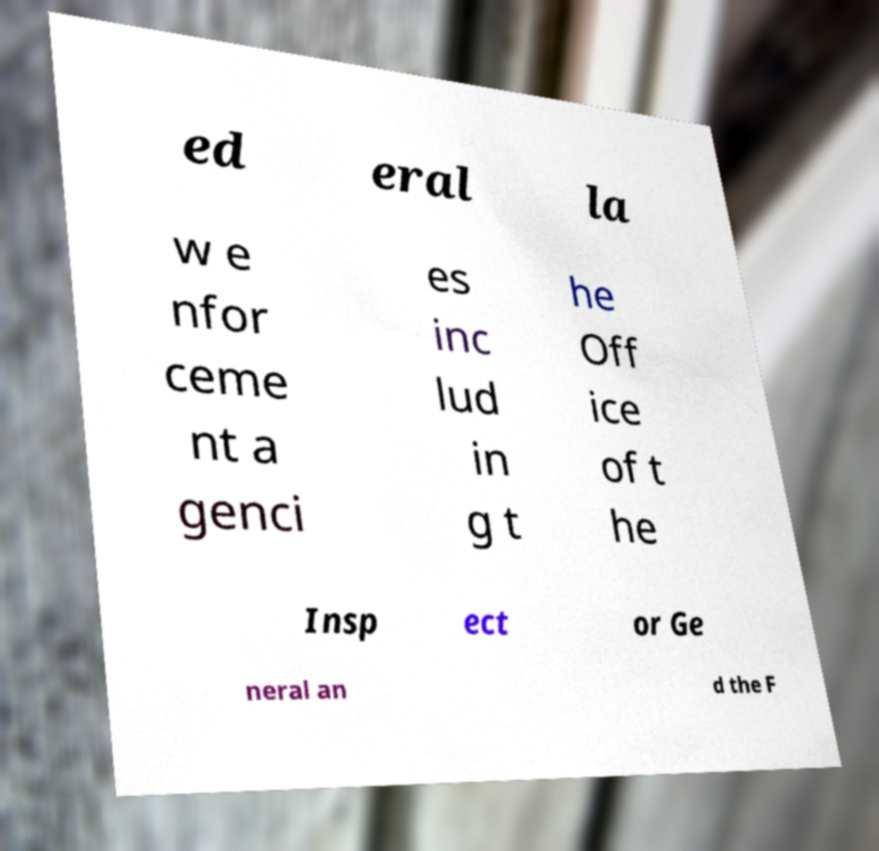Could you assist in decoding the text presented in this image and type it out clearly? ed eral la w e nfor ceme nt a genci es inc lud in g t he Off ice of t he Insp ect or Ge neral an d the F 